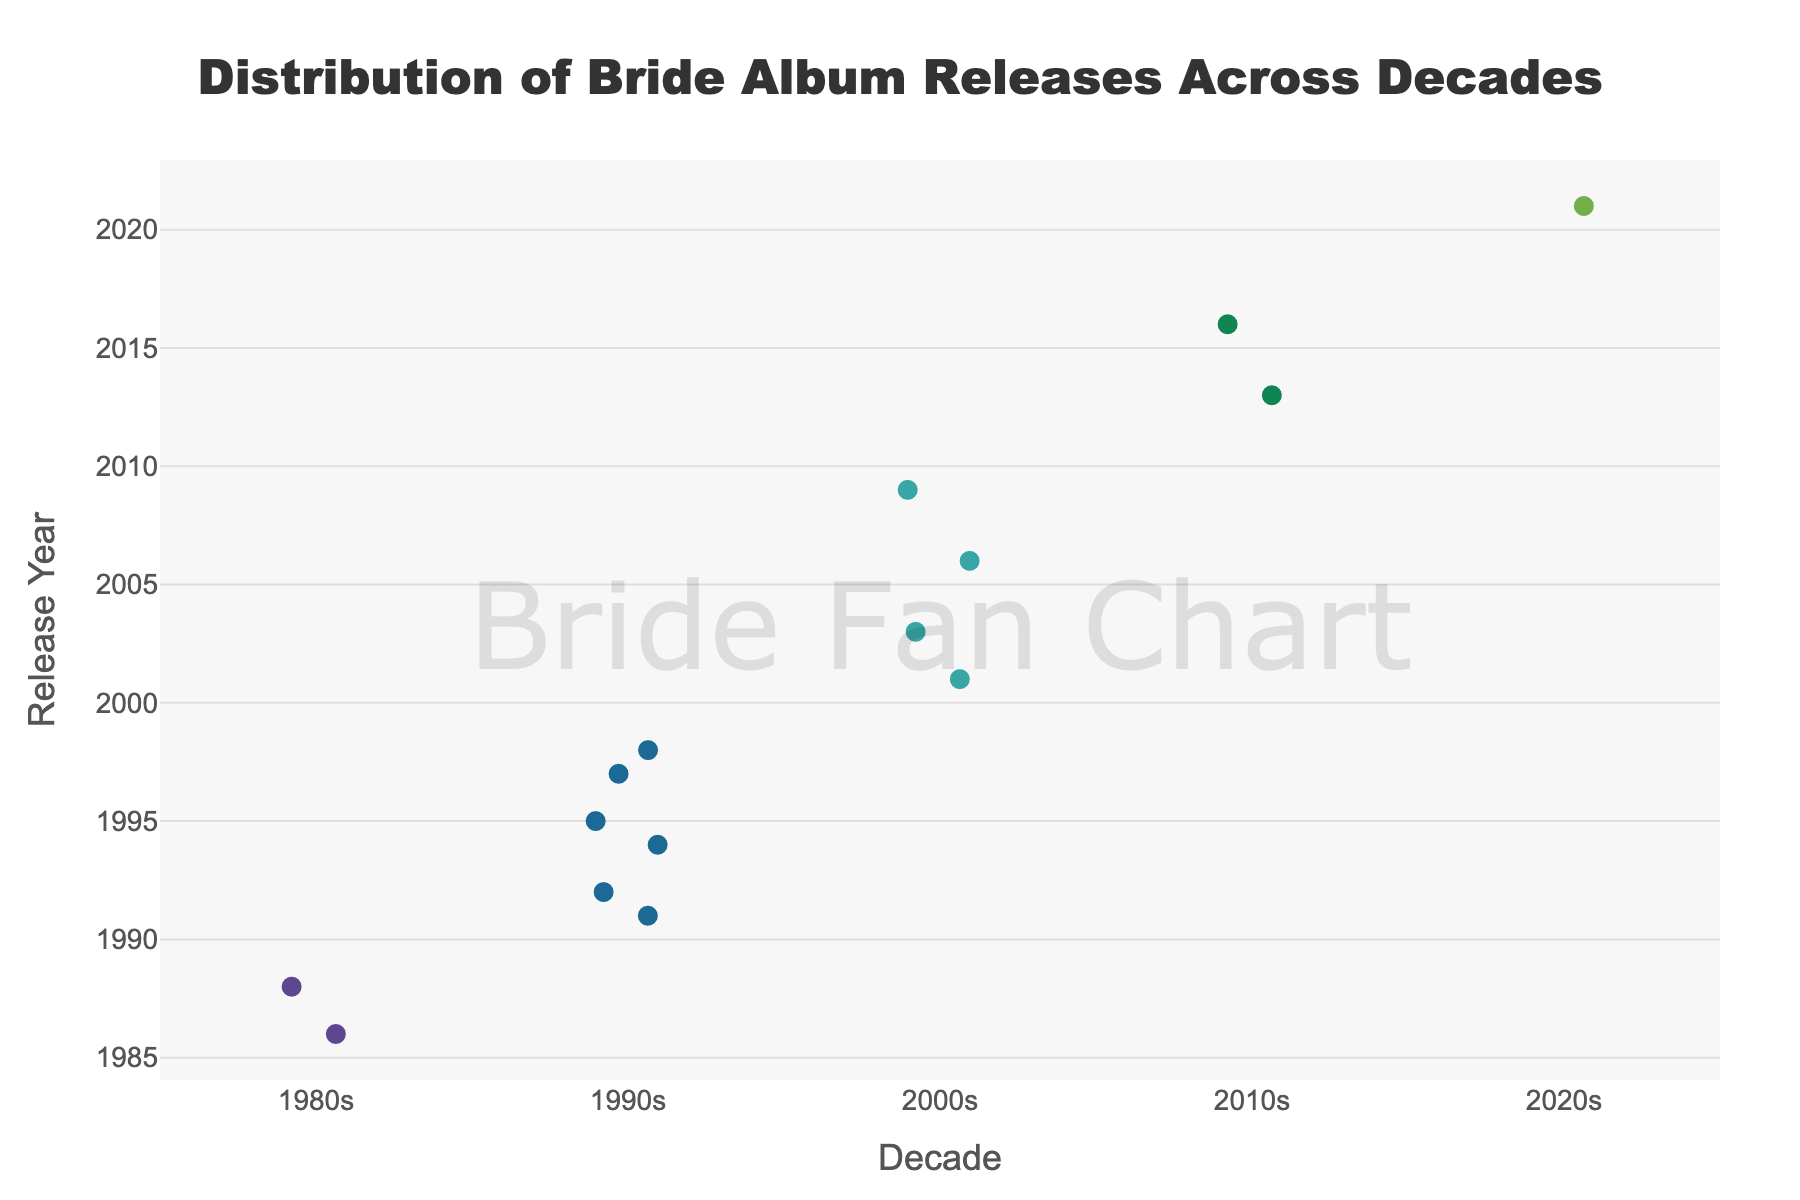What is the title of the plot? The title is prominently displayed at the top of the plot.
Answer: Distribution of Bride Album Releases Across Decades Which decade had the most album releases? Count the number of individual points within each decade grouping on the x-axis. The 1990s have the most points indicating the most releases.
Answer: 1990s What is the first album released by Bride in the 1980s according to the chart? Look at the points in the 1980s section and hover over the point with the earliest year. It shows "Show No Mercy" in 1986.
Answer: Show No Mercy How many albums were released in the 2000s? Count the number of points in the "2000s" category. There are four points corresponding to four albums.
Answer: 4 What is the latest year in which an album was released? Identify the point with the highest "Release Year" value across all decades. This point corresponds to 2021 in the 2020s.
Answer: 2021 Which decade had more album releases, the 2000s or the 2010s? Count the points in both the "2000s" and "2010s" categories. The 2000s have four points and the 2010s have two points.
Answer: 2000s What album corresponds to the latest release year in the 1990s? Look at the points in the 1990s section and hover over the point with the latest year. It shows "Oddities" in 1998.
Answer: Oddities What years had album releases in the 2010s? List the years corresponding to the points in the "2010s" category.
Answer: 2013 and 2016 How many years apart were the albums "The Jesus Experience" and "Oddities"? Identify the release years for both albums by hovering over the corresponding points in the 1990s. Subtract the smaller year from the larger year. "Oddities" (1998) - "The Jesus Experience" (1997) = 1 year apart.
Answer: 1 year What's the total number of album releases shown in the plot? Count all individual points across all decades. There are 15 points total.
Answer: 15 